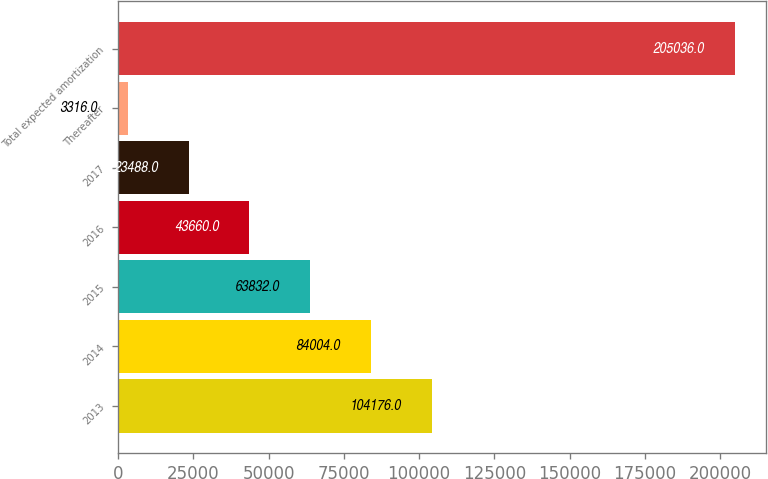Convert chart. <chart><loc_0><loc_0><loc_500><loc_500><bar_chart><fcel>2013<fcel>2014<fcel>2015<fcel>2016<fcel>2017<fcel>Thereafter<fcel>Total expected amortization<nl><fcel>104176<fcel>84004<fcel>63832<fcel>43660<fcel>23488<fcel>3316<fcel>205036<nl></chart> 